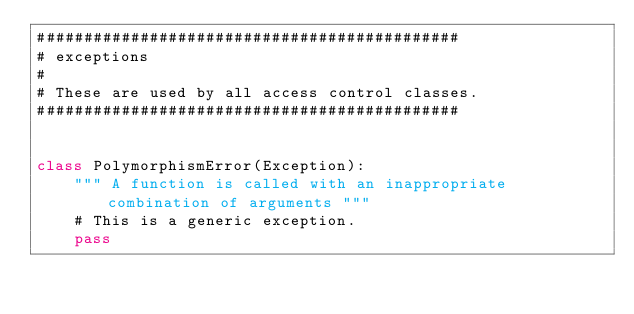Convert code to text. <code><loc_0><loc_0><loc_500><loc_500><_Python_>#############################################
# exceptions
#
# These are used by all access control classes.
#############################################


class PolymorphismError(Exception):
    """ A function is called with an inappropriate combination of arguments """
    # This is a generic exception.
    pass
</code> 